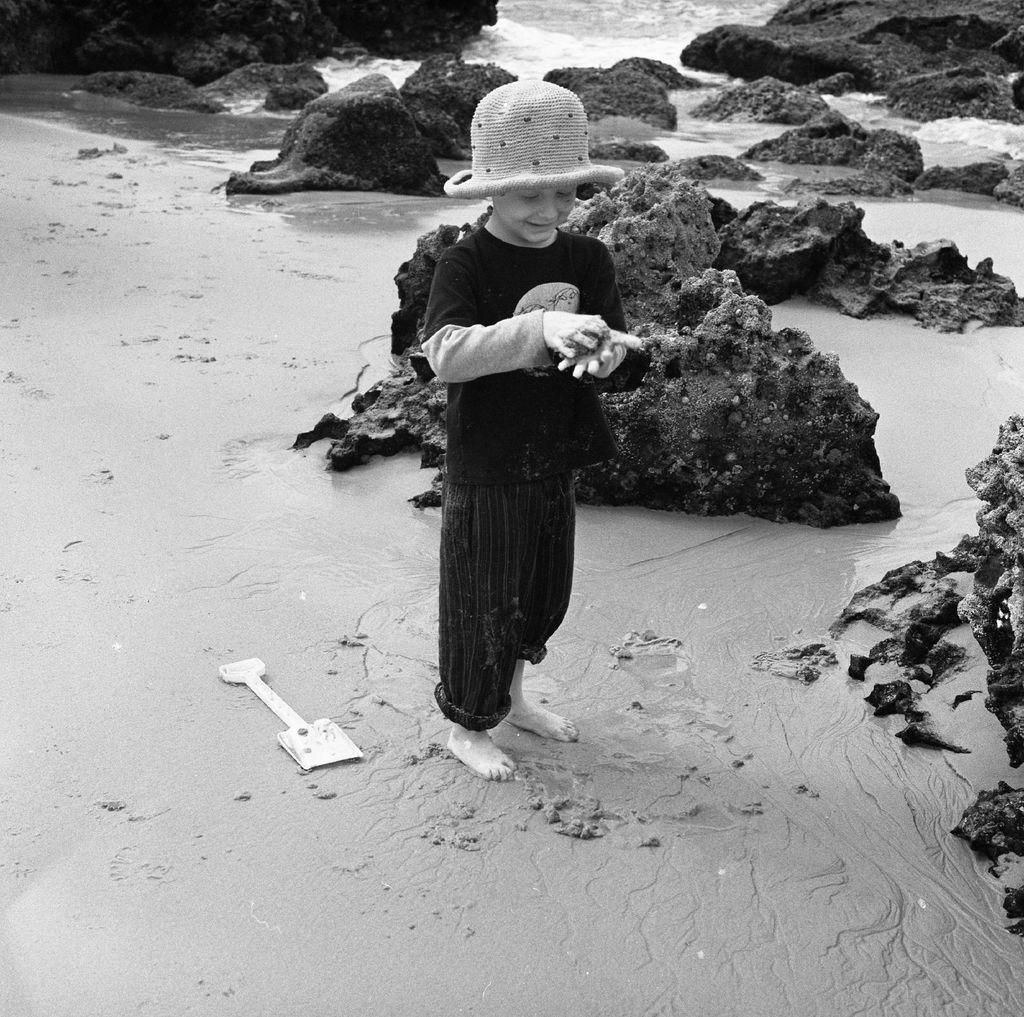What is the color scheme of the image? The image is black and white. Who or what is the main subject in the image? There is a child in the image. What is the child wearing on their head? The child is wearing a hat. What is the child holding in their hand? The child is holding something in their hand, but we cannot determine what it is from the image. What is located on the ground in the image? There is an object on the ground in the image. What type of natural elements can be seen in the image? There are rocks and water visible in the image. Can you tell me how many owls are sitting on the rocks in the image? There are no owls present in the image; it features a child wearing a hat and holding something in their hand. What type of bun is the child eating in the image? There is no bun visible in the image; the child is holding an unidentified object in their hand. 